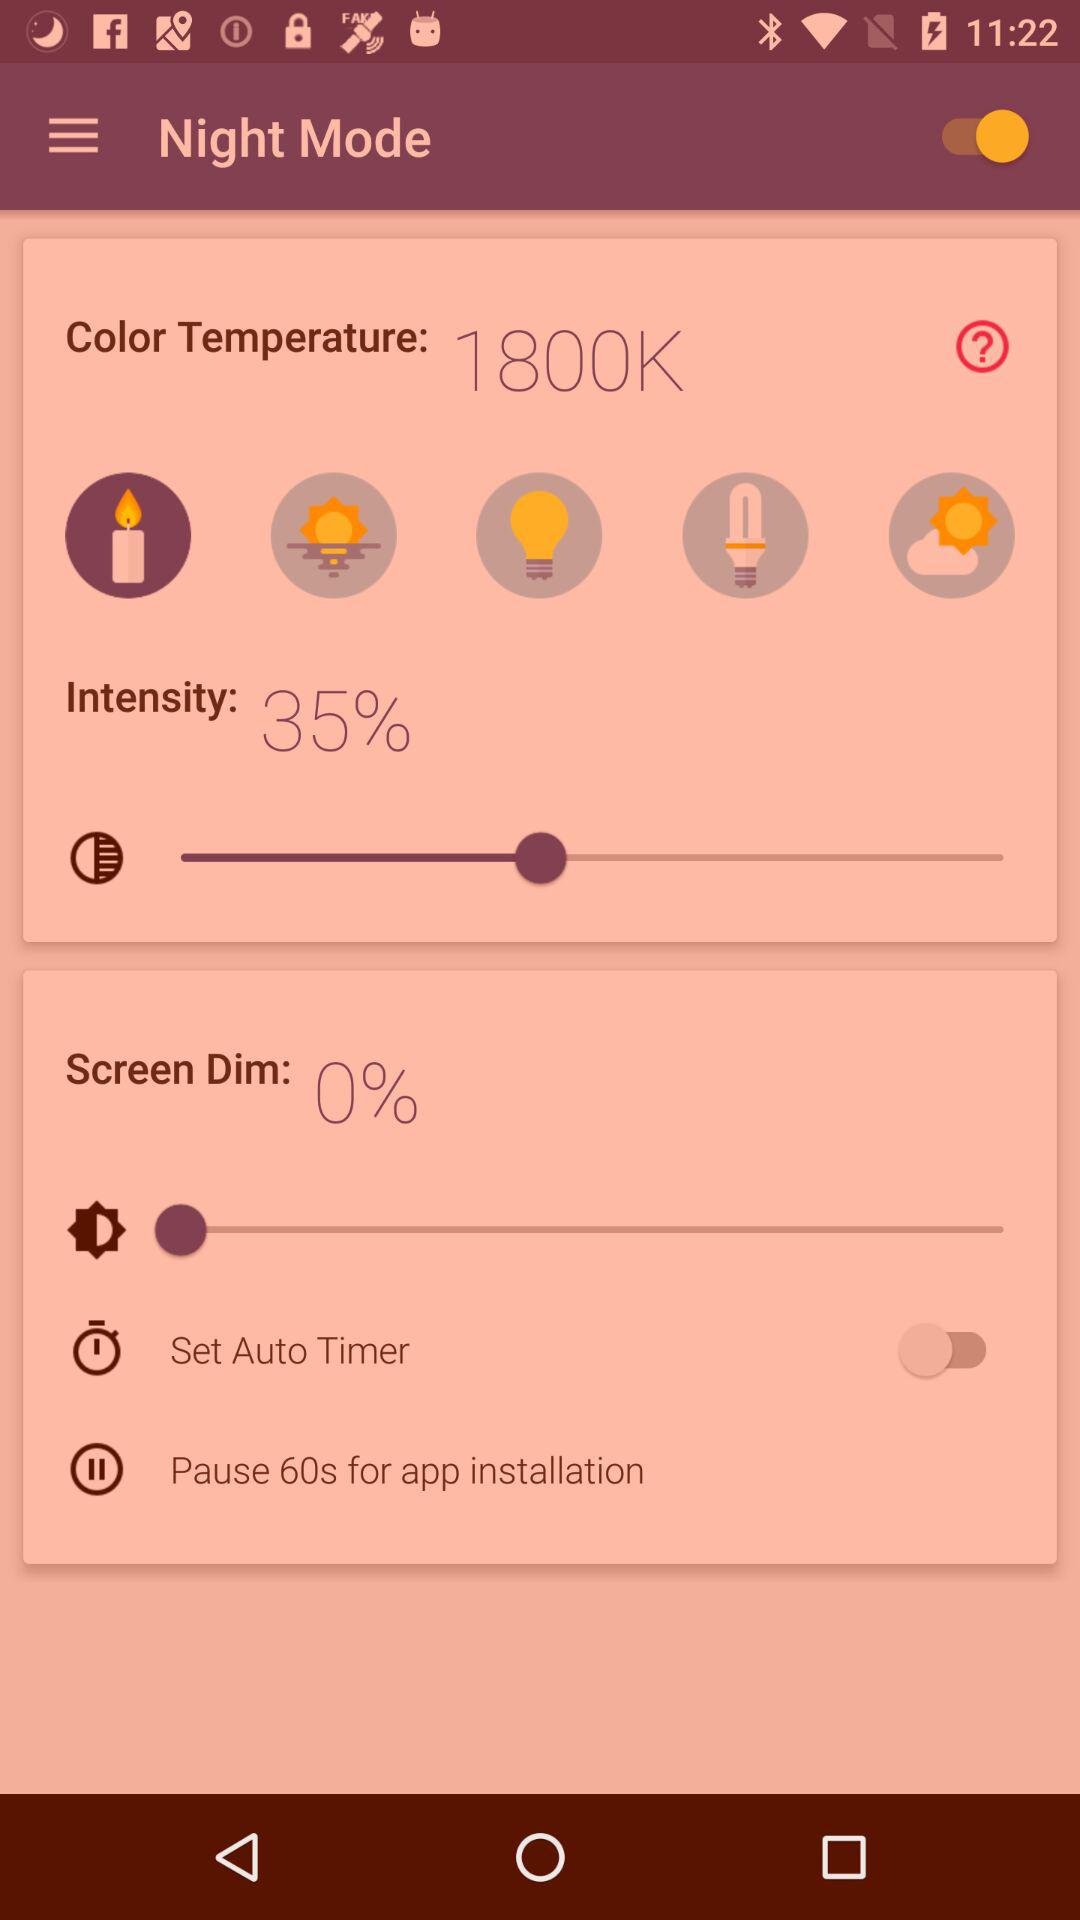Is the set auto timer on or off? The status is "off". 